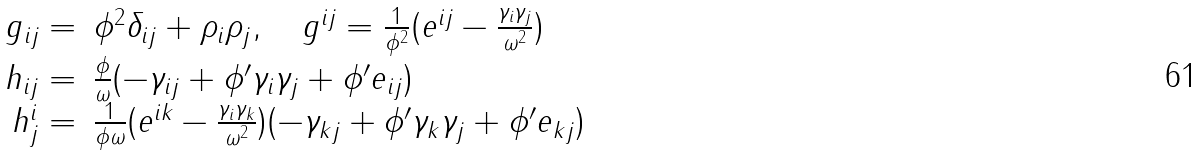<formula> <loc_0><loc_0><loc_500><loc_500>\begin{array} { r l l } g _ { i j } = & \phi ^ { 2 } \delta _ { i j } + \rho _ { i } \rho _ { j } , \quad g ^ { i j } = \frac { 1 } { \phi ^ { 2 } } ( e ^ { i j } - \frac { \gamma _ { i } \gamma _ { j } } { \omega ^ { 2 } } ) \\ h _ { i j } = & \frac { \phi } { \omega } ( - \gamma _ { i j } + \phi ^ { \prime } \gamma _ { i } \gamma _ { j } + \phi ^ { \prime } e _ { i j } ) \\ h ^ { i } _ { j } = & \frac { 1 } { \phi \omega } ( e ^ { i k } - \frac { \gamma _ { i } \gamma _ { k } } { \omega ^ { 2 } } ) ( - \gamma _ { k j } + \phi ^ { \prime } \gamma _ { k } \gamma _ { j } + \phi ^ { \prime } e _ { k j } ) \end{array}</formula> 